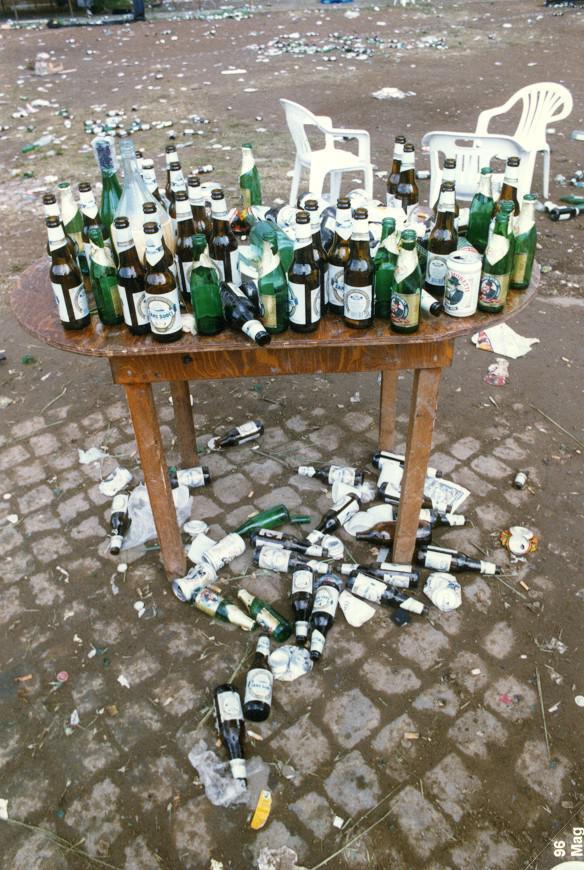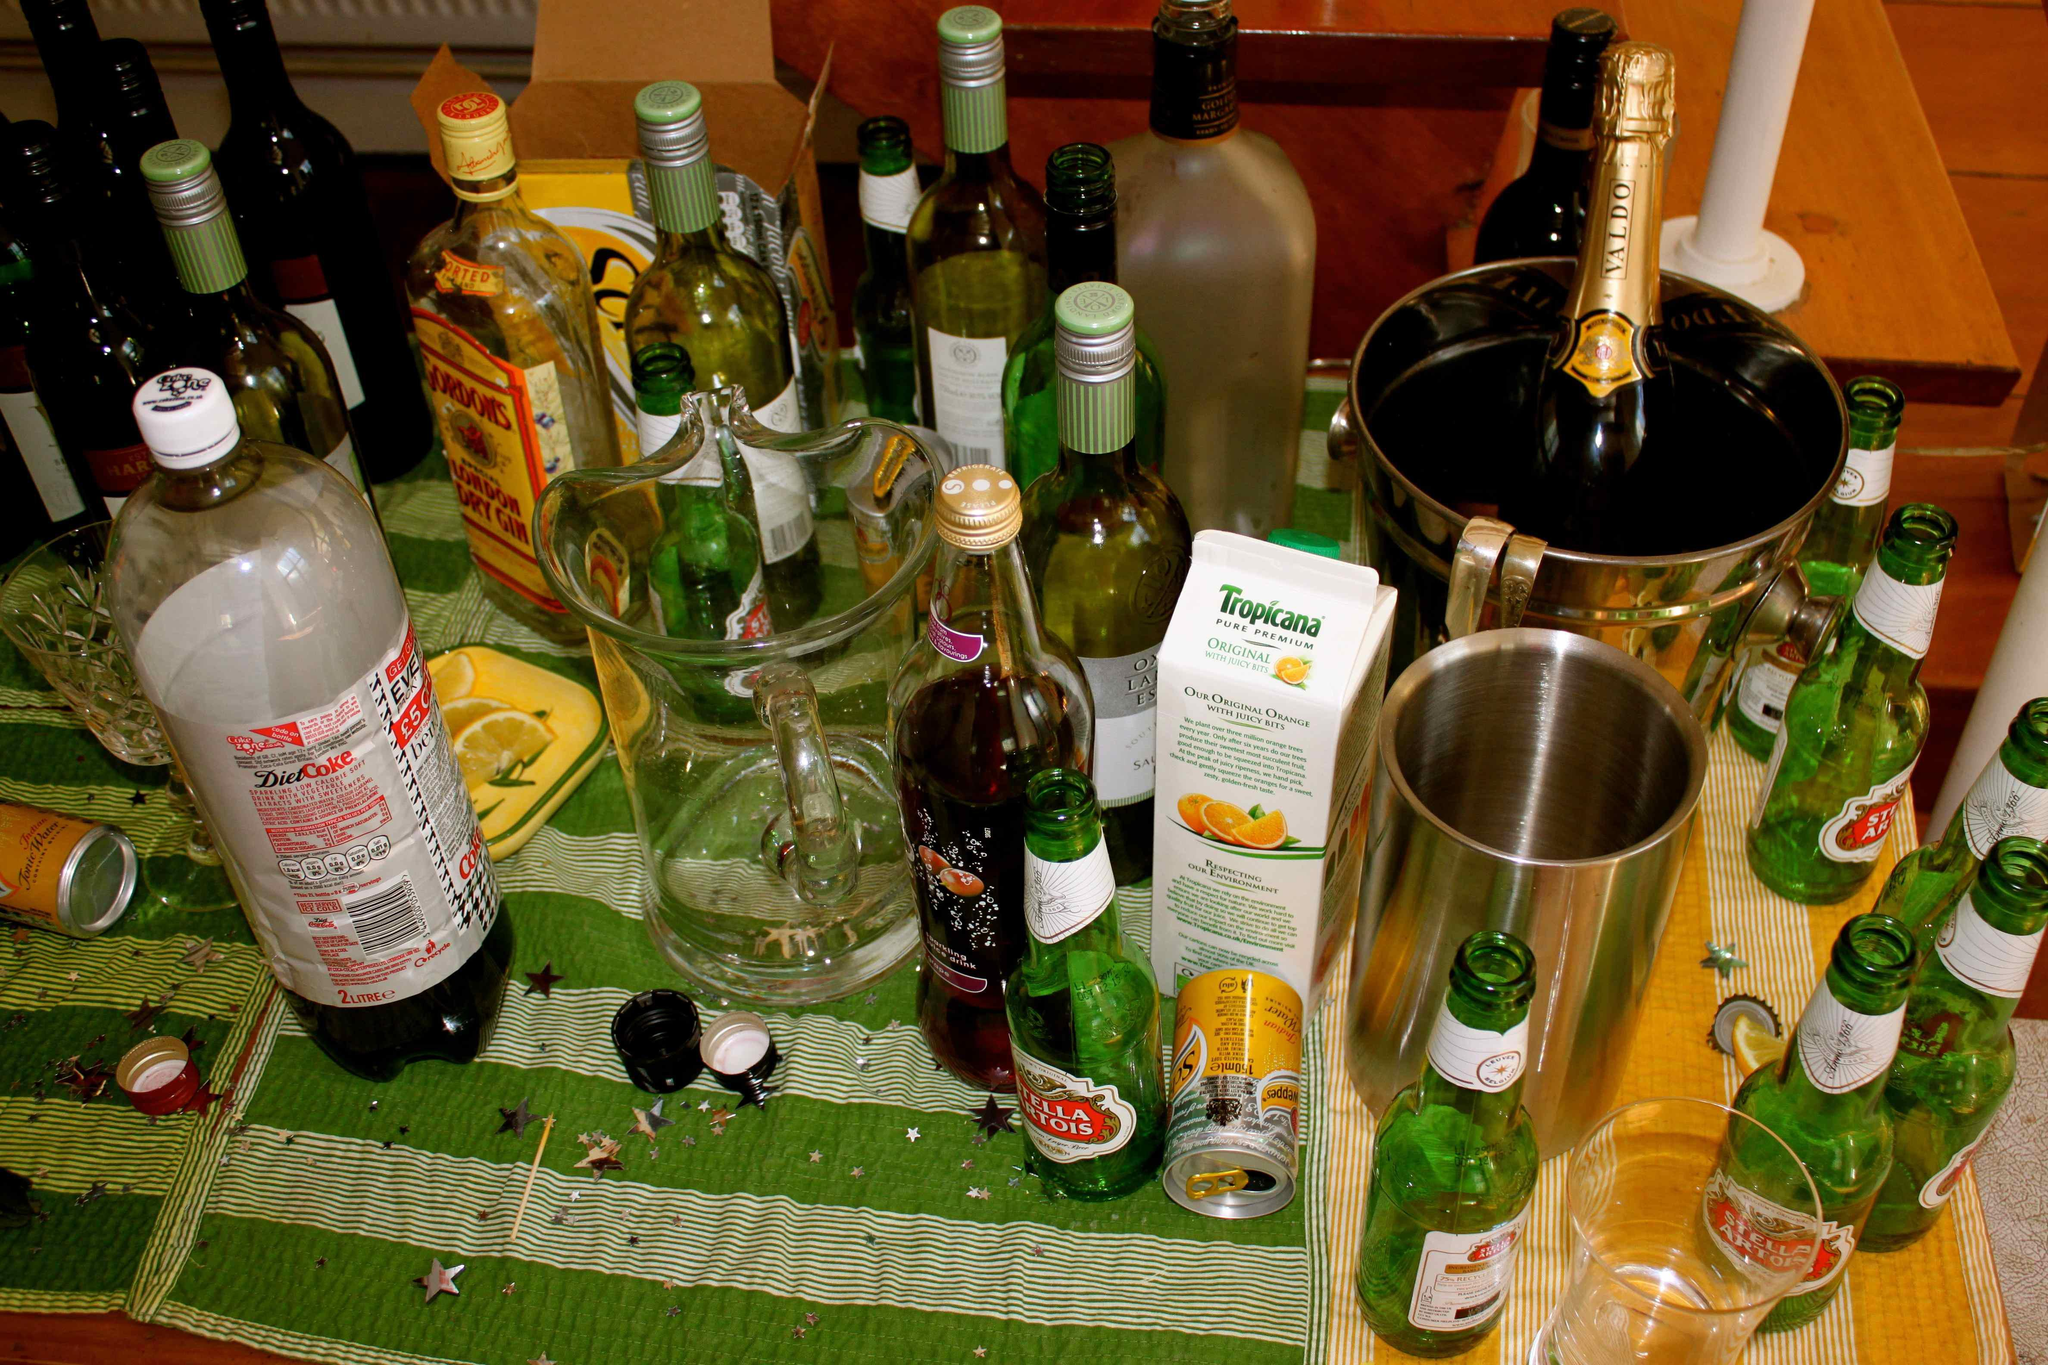The first image is the image on the left, the second image is the image on the right. Considering the images on both sides, is "There is sun coming in through the window in the left image." valid? Answer yes or no. No. The first image is the image on the left, the second image is the image on the right. Given the left and right images, does the statement "There is one brown table outside with at least 10 open bottles." hold true? Answer yes or no. Yes. 